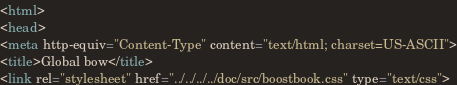Convert code to text. <code><loc_0><loc_0><loc_500><loc_500><_HTML_><html>
<head>
<meta http-equiv="Content-Type" content="text/html; charset=US-ASCII">
<title>Global bow</title>
<link rel="stylesheet" href="../../../../doc/src/boostbook.css" type="text/css"></code> 